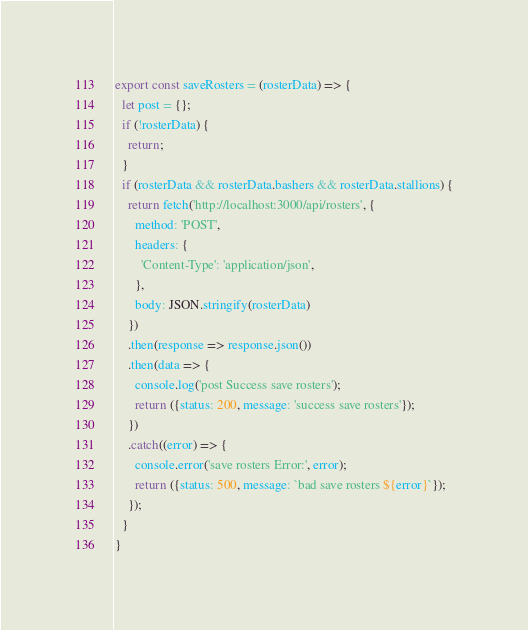Convert code to text. <code><loc_0><loc_0><loc_500><loc_500><_JavaScript_>export const saveRosters = (rosterData) => {
  let post = {};
  if (!rosterData) {
    return;
  }
  if (rosterData && rosterData.bashers && rosterData.stallions) {
    return fetch('http://localhost:3000/api/rosters', {
      method: 'POST',
      headers: {
        'Content-Type': 'application/json',
      }, 
      body: JSON.stringify(rosterData) 
    })
    .then(response => response.json())
    .then(data => {
      console.log('post Success save rosters');
      return ({status: 200, message: 'success save rosters'});
    })
    .catch((error) => {
      console.error('save rosters Error:', error);      
      return ({status: 500, message: `bad save rosters ${error}`});
    });
  }
}

</code> 